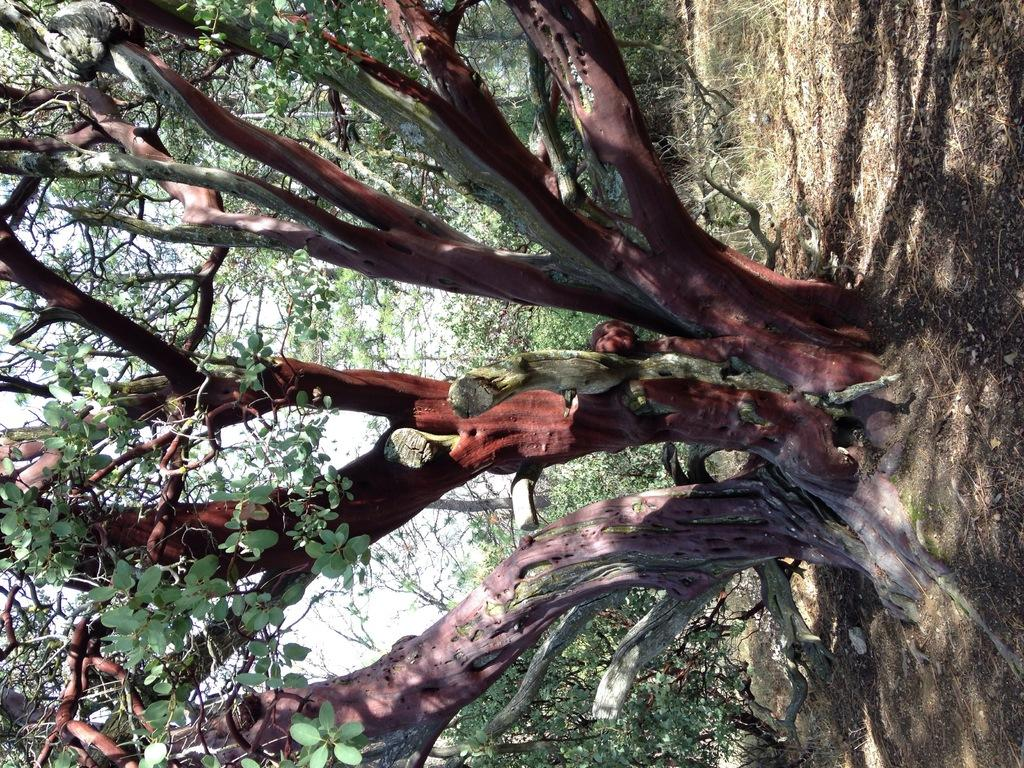What type of vegetation can be seen in the image? There are trees in the image. What type of ground cover is present in the image? There is grass in the image. What type of fiction is being read by the laborer in the image? There is no laborer or fiction present in the image; it only features trees and grass. How does the wind blow the trees in the image? The image does not depict the wind blowing the trees; it only shows the trees and grass in a still state. 